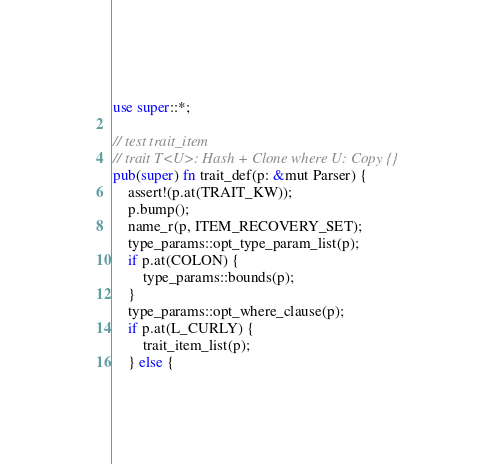Convert code to text. <code><loc_0><loc_0><loc_500><loc_500><_Rust_>use super::*;

// test trait_item
// trait T<U>: Hash + Clone where U: Copy {}
pub(super) fn trait_def(p: &mut Parser) {
    assert!(p.at(TRAIT_KW));
    p.bump();
    name_r(p, ITEM_RECOVERY_SET);
    type_params::opt_type_param_list(p);
    if p.at(COLON) {
        type_params::bounds(p);
    }
    type_params::opt_where_clause(p);
    if p.at(L_CURLY) {
        trait_item_list(p);
    } else {</code> 